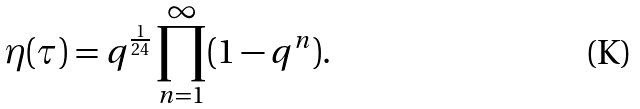<formula> <loc_0><loc_0><loc_500><loc_500>\eta ( \tau ) = q ^ { \frac { 1 } { 2 4 } } \prod _ { n = 1 } ^ { \infty } ( 1 - q ^ { n } ) .</formula> 